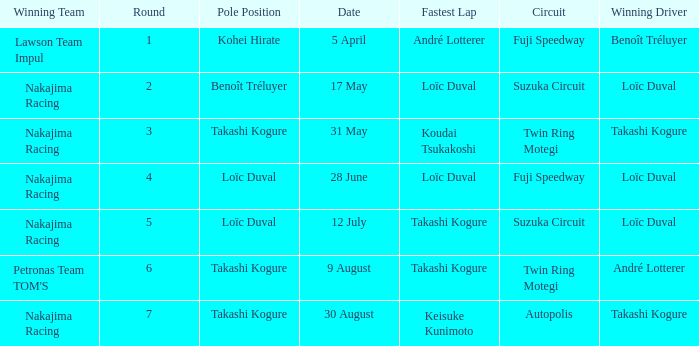What was the earlier round where Takashi Kogure got the fastest lap? 5.0. 